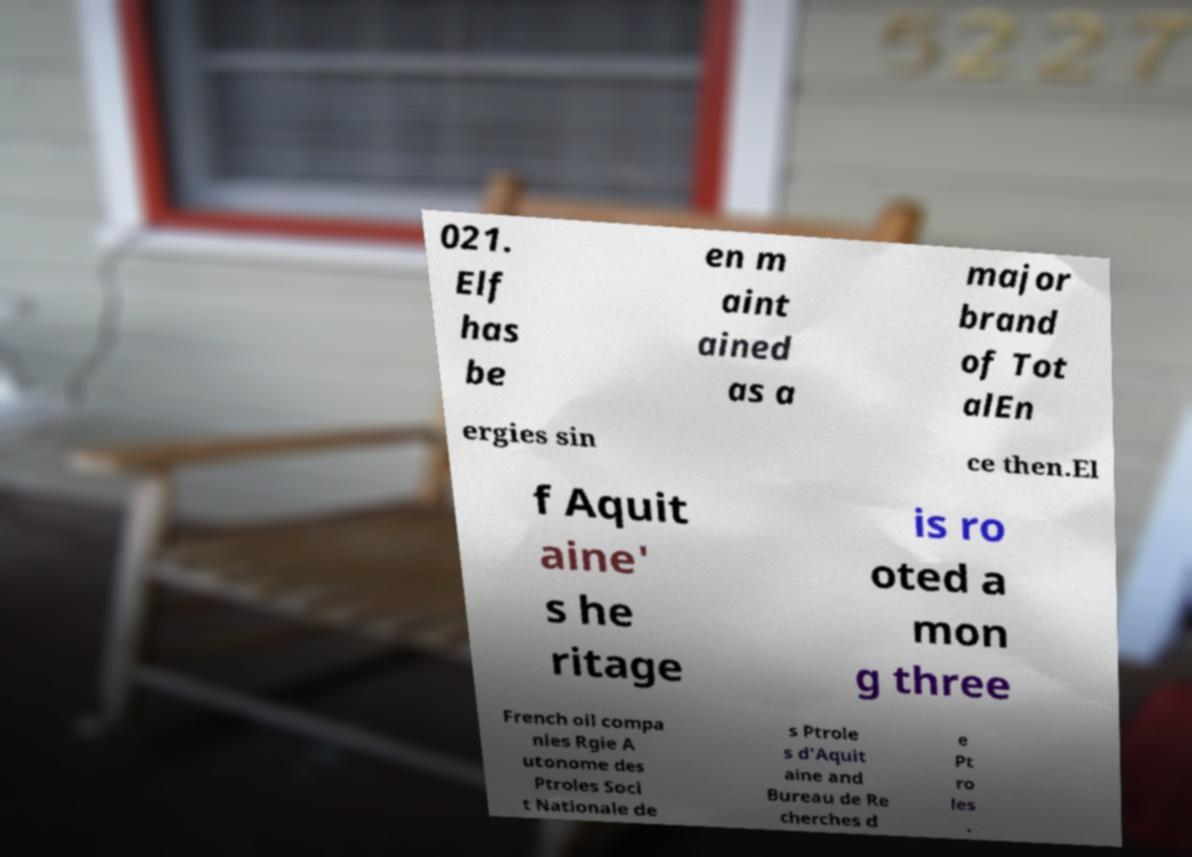Could you extract and type out the text from this image? 021. Elf has be en m aint ained as a major brand of Tot alEn ergies sin ce then.El f Aquit aine' s he ritage is ro oted a mon g three French oil compa nies Rgie A utonome des Ptroles Soci t Nationale de s Ptrole s d'Aquit aine and Bureau de Re cherches d e Pt ro les . 